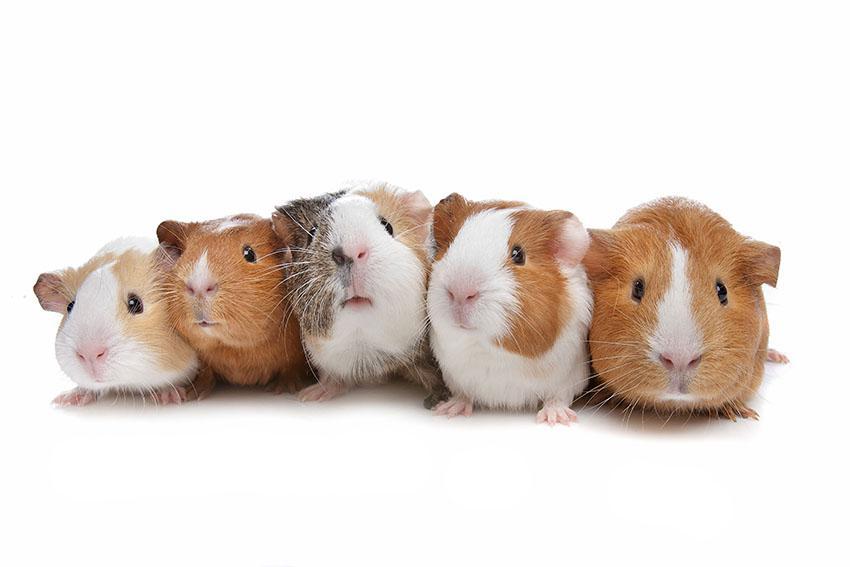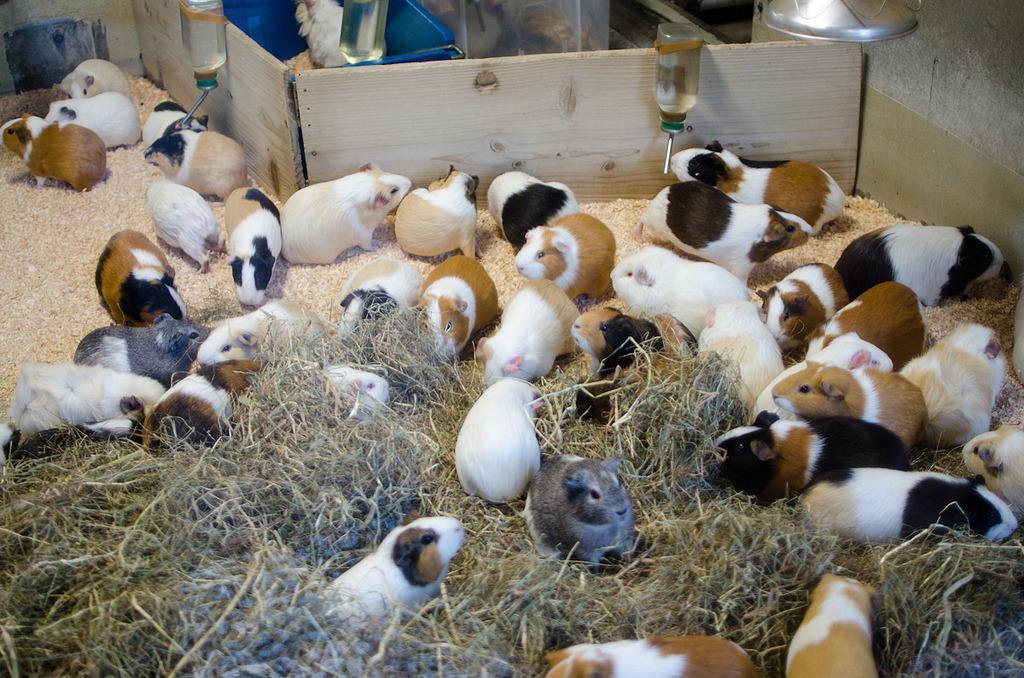The first image is the image on the left, the second image is the image on the right. For the images shown, is this caption "There are no more than five animals in one of the images" true? Answer yes or no. Yes. The first image is the image on the left, the second image is the image on the right. Considering the images on both sides, is "At least one image shows guinea pigs lined up on three steps." valid? Answer yes or no. No. The first image is the image on the left, the second image is the image on the right. For the images shown, is this caption "An image shows a horizontal row of no more than five hamsters." true? Answer yes or no. Yes. 